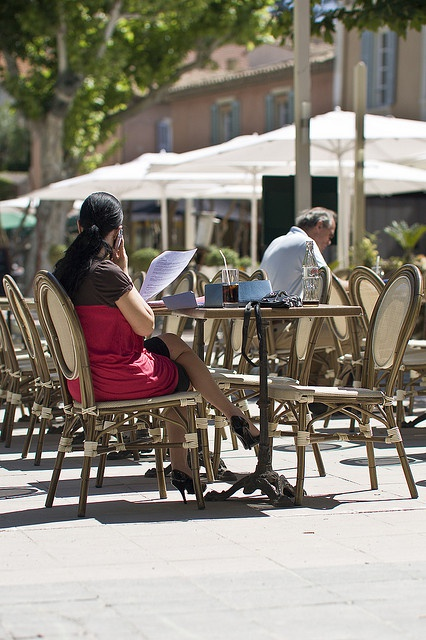Describe the objects in this image and their specific colors. I can see people in black, maroon, and gray tones, chair in black, gray, and maroon tones, chair in black, gray, and tan tones, dining table in black, gray, and maroon tones, and people in black, darkgray, gray, and lightgray tones in this image. 